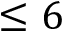Convert formula to latex. <formula><loc_0><loc_0><loc_500><loc_500>\leq { 6 }</formula> 